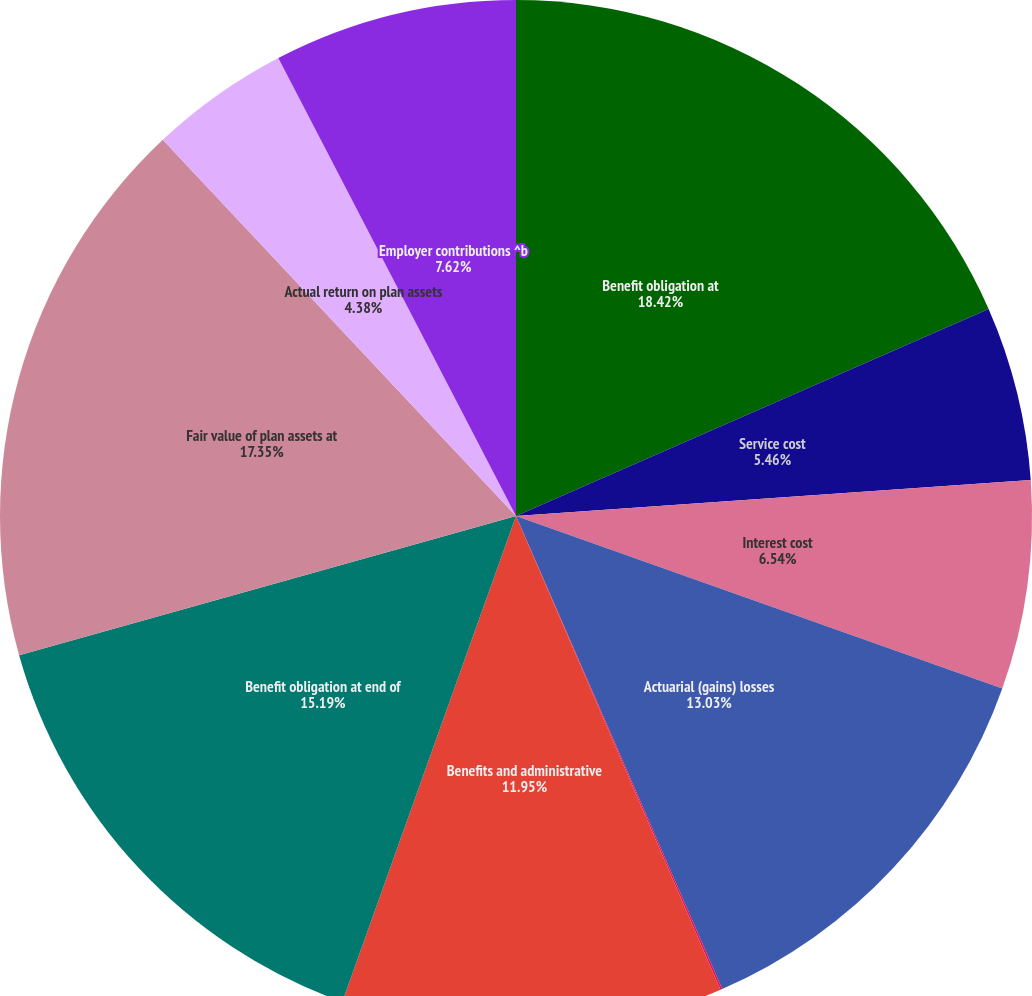Convert chart. <chart><loc_0><loc_0><loc_500><loc_500><pie_chart><fcel>Benefit obligation at<fcel>Service cost<fcel>Interest cost<fcel>Actuarial (gains) losses<fcel>Foreign exchange (gains)<fcel>Benefits and administrative<fcel>Benefit obligation at end of<fcel>Fair value of plan assets at<fcel>Actual return on plan assets<fcel>Employer contributions ^b<nl><fcel>18.43%<fcel>5.46%<fcel>6.54%<fcel>13.03%<fcel>0.06%<fcel>11.95%<fcel>15.19%<fcel>17.35%<fcel>4.38%<fcel>7.62%<nl></chart> 